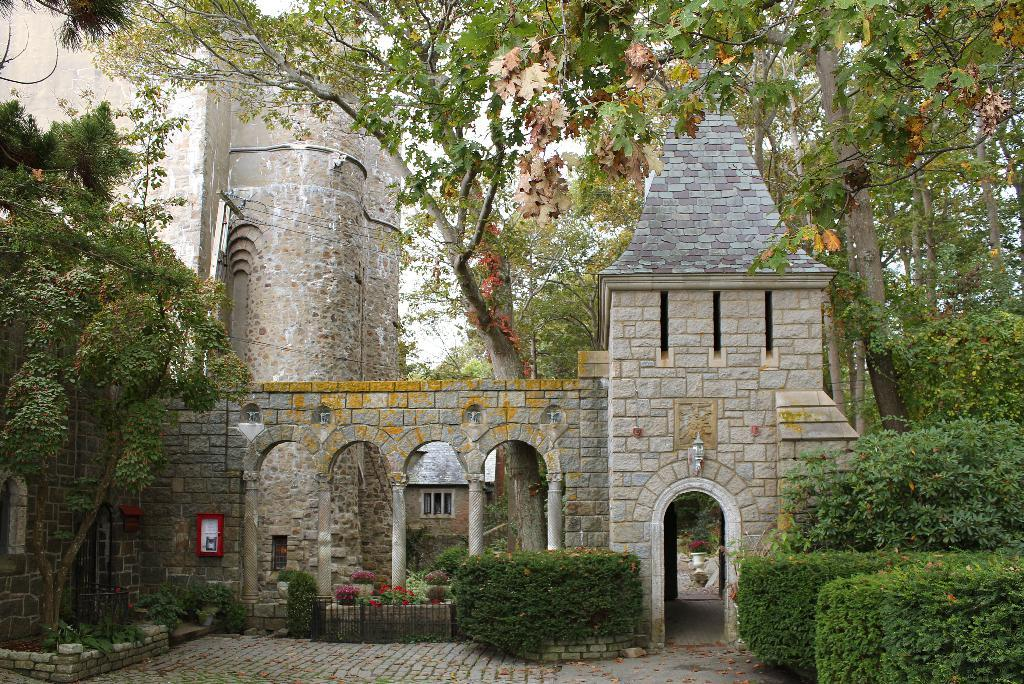What is the main structure in the image? There is a building in the image. What type of natural elements are present around the building? There are trees and plants around the building. How does the island in the image affect the building's location? There is no island present in the image; it only features a building surrounded by trees and plants. 